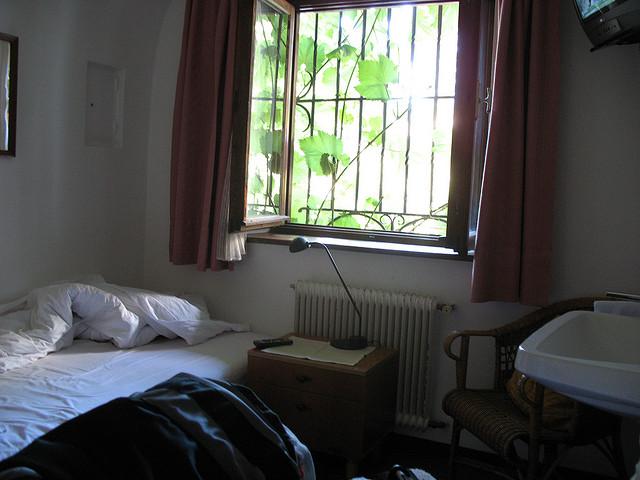Is the phone cordless?
Quick response, please. Yes. Is there snow outside?
Write a very short answer. No. How many light sources are there?
Give a very brief answer. 2. Is there a tree outside the window?
Be succinct. Yes. What color are the curtains?
Give a very brief answer. Brown. Are both the windows open?
Concise answer only. Yes. What kind of curtains are those?
Give a very brief answer. Cloth. Is the bed messy?
Write a very short answer. Yes. What color are the non-green leaves visible through the window?
Quick response, please. Brown. What color is the bowl?
Write a very short answer. White. How many beds are in the room?
Quick response, please. 1. Is the room ready?
Answer briefly. No. What type of print is on the curtain?
Short answer required. None. Is it likely to snow today?
Write a very short answer. No. What is in the corner of this room?
Concise answer only. Bed. 